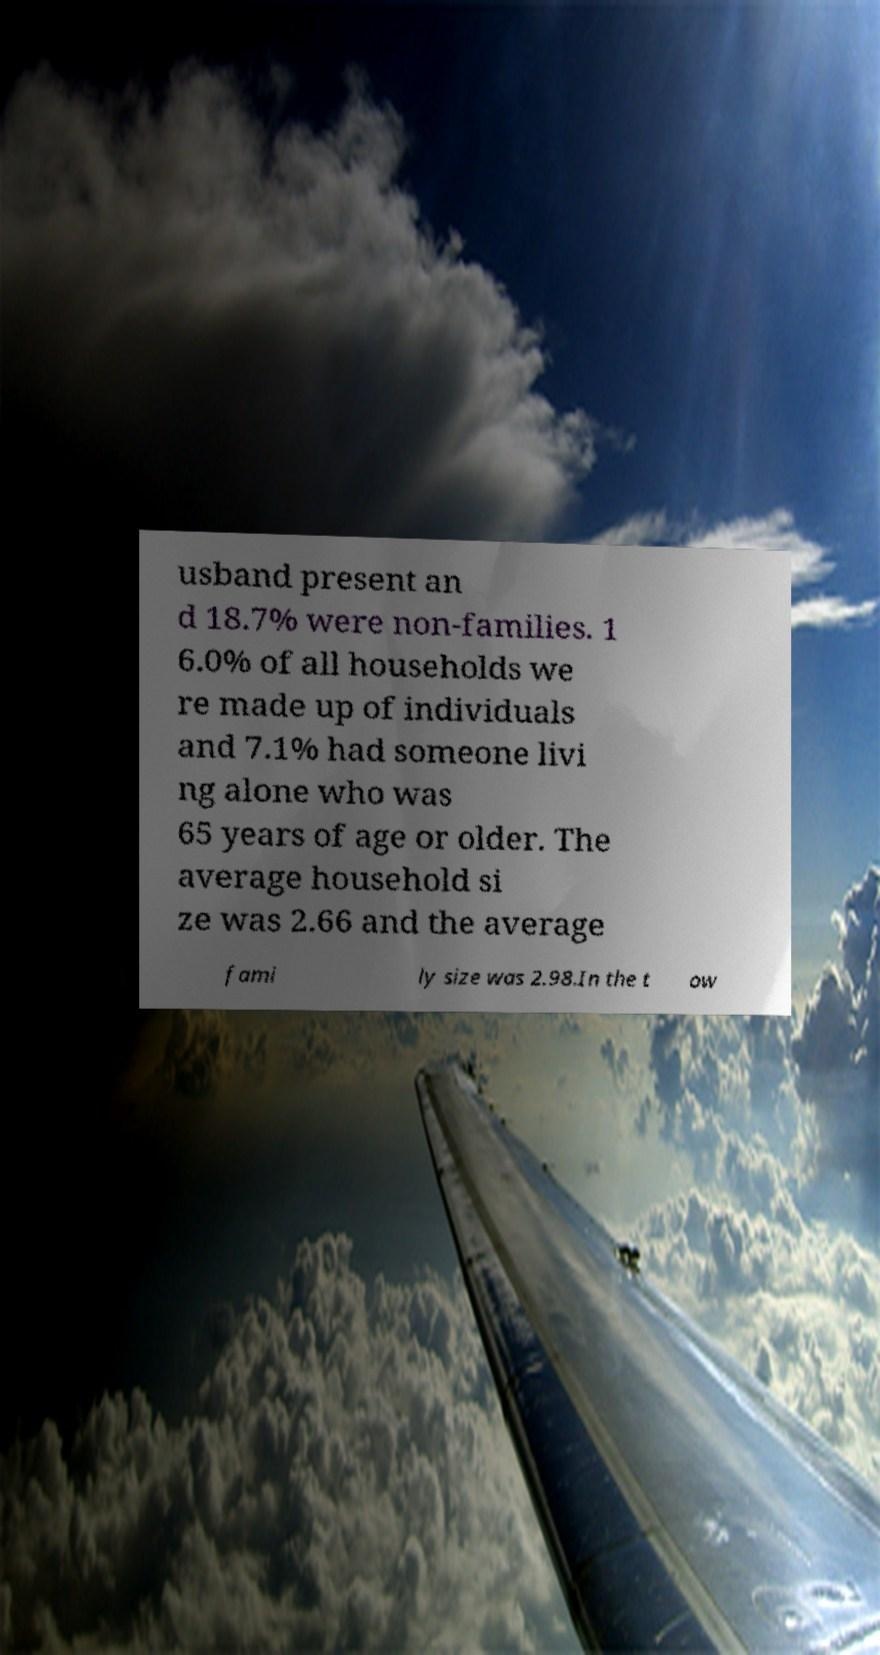Please read and relay the text visible in this image. What does it say? usband present an d 18.7% were non-families. 1 6.0% of all households we re made up of individuals and 7.1% had someone livi ng alone who was 65 years of age or older. The average household si ze was 2.66 and the average fami ly size was 2.98.In the t ow 